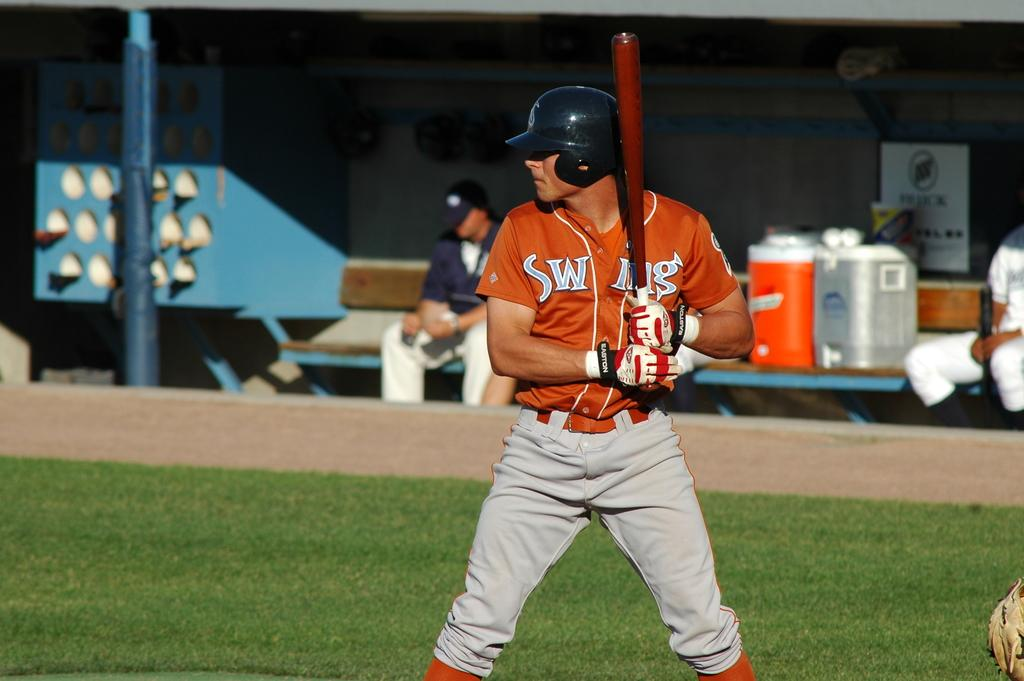<image>
Give a short and clear explanation of the subsequent image. a person in an orange SWING jersey holds a bat 